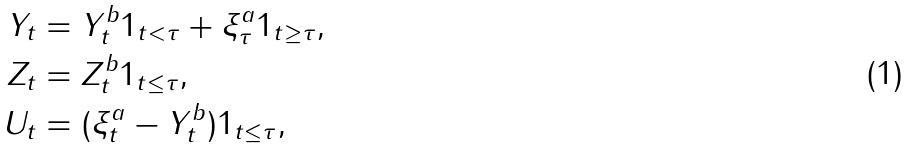<formula> <loc_0><loc_0><loc_500><loc_500>Y _ { t } & = Y _ { t } ^ { b } 1 _ { t < \tau } + \xi ^ { a } _ { \tau } 1 _ { t \geq \tau } , \\ Z _ { t } & = Z _ { t } ^ { b } 1 _ { t \leq \tau } , \\ U _ { t } & = ( \xi ^ { a } _ { t } - Y _ { t } ^ { b } ) 1 _ { t \leq \tau } ,</formula> 